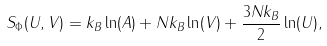<formula> <loc_0><loc_0><loc_500><loc_500>S _ { \Phi } ( U , V ) = k _ { B } \ln ( A ) + N k _ { B } \ln ( V ) + \frac { 3 N k _ { B } } { 2 } \ln ( U ) ,</formula> 